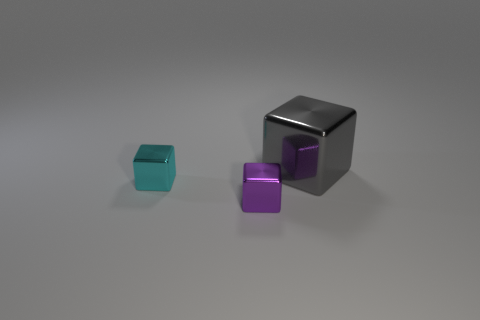Add 3 cyan blocks. How many objects exist? 6 Subtract all metal blocks. Subtract all small red balls. How many objects are left? 0 Add 1 gray things. How many gray things are left? 2 Add 3 tiny yellow metallic things. How many tiny yellow metallic things exist? 3 Subtract 0 green spheres. How many objects are left? 3 